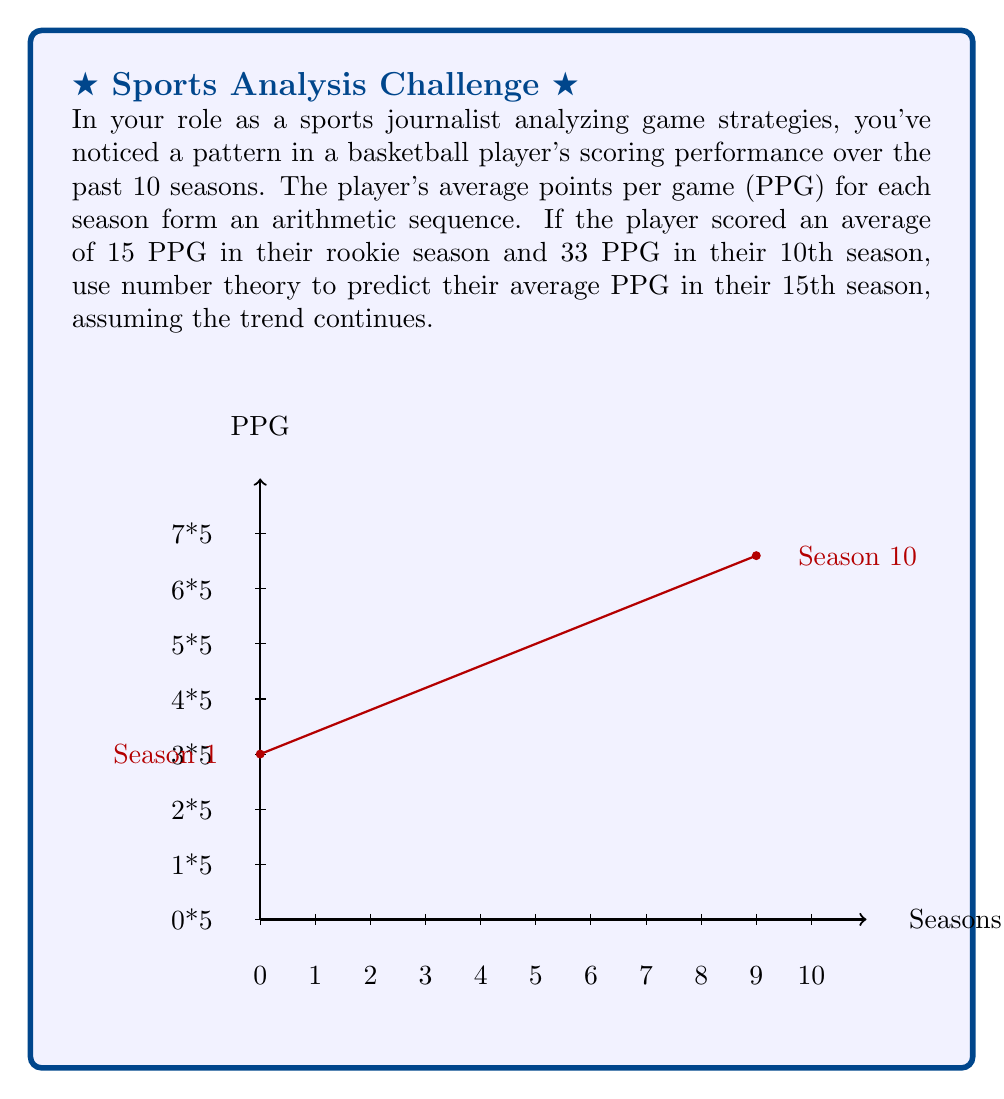Could you help me with this problem? To solve this problem, we'll use arithmetic sequence properties and number theory concepts:

1) In an arithmetic sequence, the difference between any two consecutive terms is constant. Let's call this common difference $d$.

2) We can find $d$ using the first term $a_1 = 15$ and the 10th term $a_{10} = 33$:
   $$a_n = a_1 + (n-1)d$$
   $$33 = 15 + (10-1)d$$
   $$18 = 9d$$
   $$d = 2$$

3) Now we can verify the arithmetic sequence:
   $a_1 = 15$
   $a_2 = 15 + 2 = 17$
   $a_3 = 17 + 2 = 19$
   ...
   $a_{10} = 33$

4) To find the 15th term, we can use the same formula:
   $$a_{15} = a_1 + (15-1)d$$
   $$a_{15} = 15 + (14)(2)$$
   $$a_{15} = 15 + 28 = 43$$

5) We can also use the general term formula for arithmetic sequences:
   $$a_n = a_1 + (n-1)d$$
   $$a_{15} = 15 + (15-1)(2) = 15 + 28 = 43$$

Thus, using number theory and arithmetic sequence properties, we predict that the player will average 43 PPG in their 15th season if the trend continues.
Answer: 43 PPG 